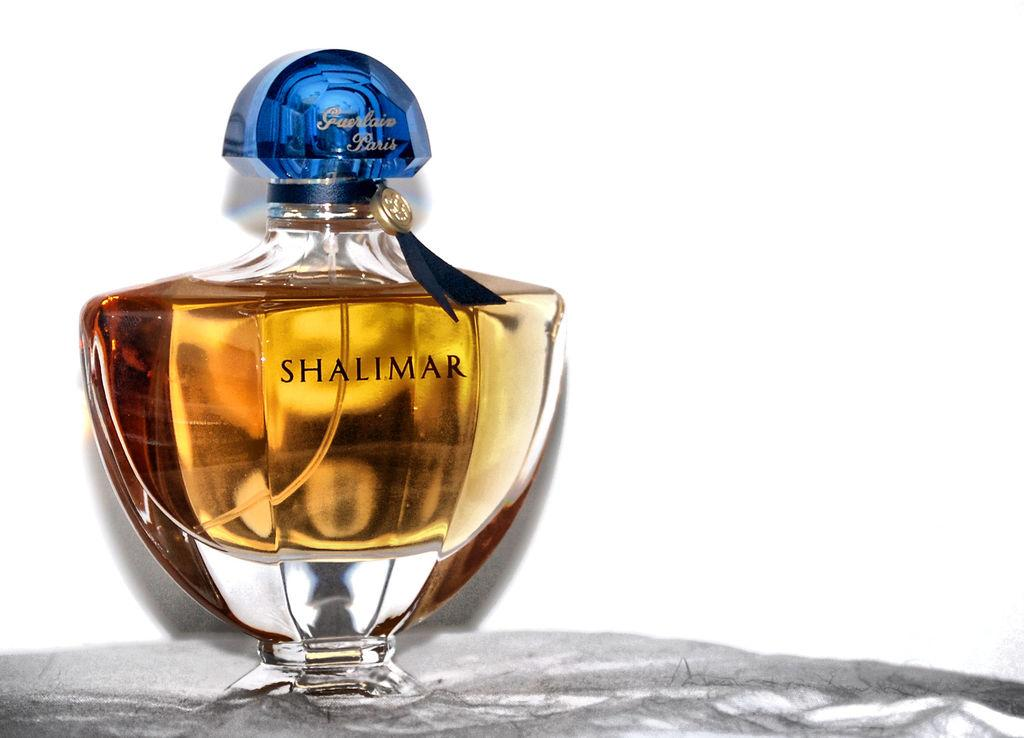Provide a one-sentence caption for the provided image. Bottle of Shalimar with a blue cap on a surface. 